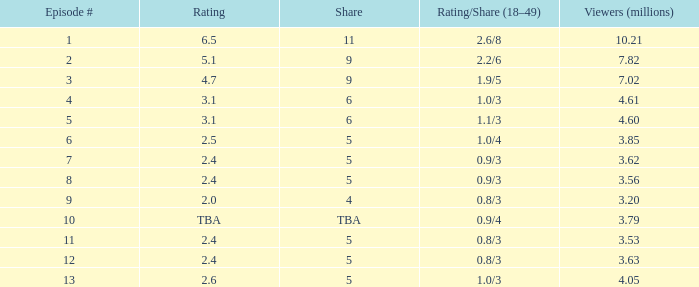Parse the full table. {'header': ['Episode #', 'Rating', 'Share', 'Rating/Share (18–49)', 'Viewers (millions)'], 'rows': [['1', '6.5', '11', '2.6/8', '10.21'], ['2', '5.1', '9', '2.2/6', '7.82'], ['3', '4.7', '9', '1.9/5', '7.02'], ['4', '3.1', '6', '1.0/3', '4.61'], ['5', '3.1', '6', '1.1/3', '4.60'], ['6', '2.5', '5', '1.0/4', '3.85'], ['7', '2.4', '5', '0.9/3', '3.62'], ['8', '2.4', '5', '0.9/3', '3.56'], ['9', '2.0', '4', '0.8/3', '3.20'], ['10', 'TBA', 'TBA', '0.9/4', '3.79'], ['11', '2.4', '5', '0.8/3', '3.53'], ['12', '2.4', '5', '0.8/3', '3.63'], ['13', '2.6', '5', '1.0/3', '4.05']]} What is the earliest episode that achieved a None. 